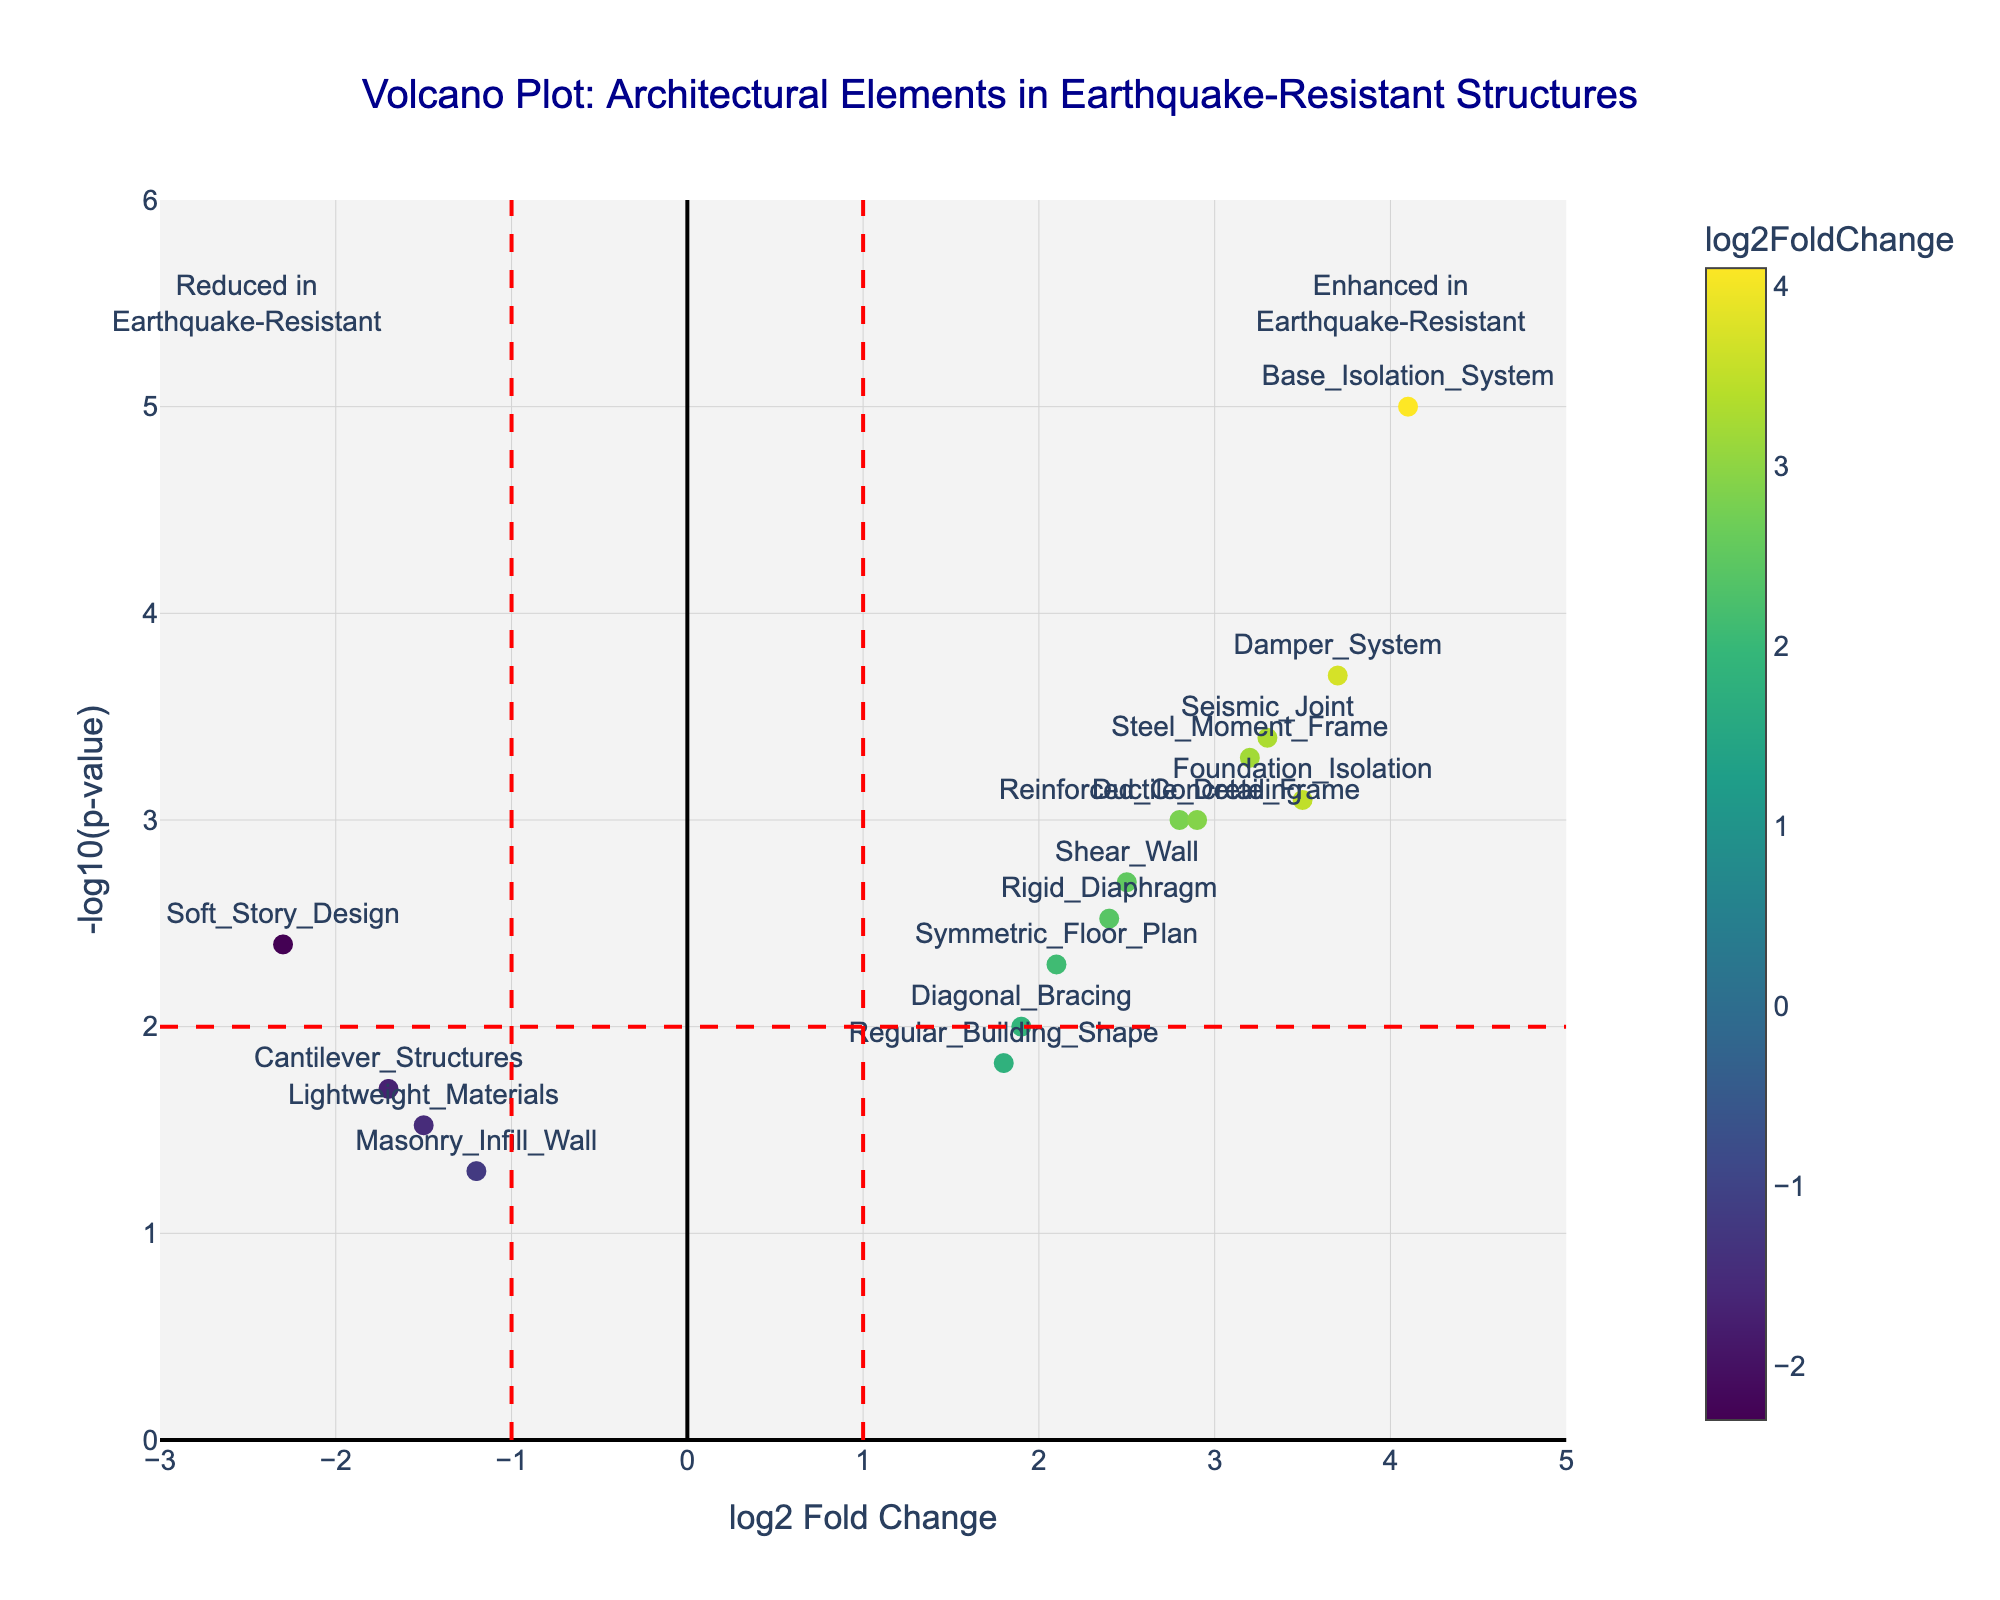What is the title of the figure? The title is usually located at the top of the figure, and it states what the plot represents.
Answer: Volcano Plot: Architectural Elements in Earthquake-Resistant Structures What are the axes labels in the plot? The x-axis label is "log2 Fold Change" and the y-axis label is "-log10(p-value)". These labels provide information on what each axis represents.
Answer: log2 Fold Change, -log10(p-value) How many architectural elements show a positive log2 fold change greater than 1? Elements with a positive log2 fold change greater than 1 are those that fall to the right of the vertical line at x=1, which is drawn in red. Count the number of points that meet this criterion.
Answer: 10 Which architectural element has the highest -log10(p-value)? The highest -log10(p-value) corresponds to the point located furthest up on the y-axis, representing the element with the strongest statistical significance.
Answer: Base_Isolation_System What is the log2 Fold Change and -log10(p-value) for the element "Soft_Story_Design"? Locate the point labeled "Soft_Story_Design" and read the corresponding x (log2 Fold Change) and y (-log10(p-value)) values from the plot.
Answer: -2.3, 2.40 How does the log2 Fold Change of "Reinforced_Concrete_Frame" compare to "Steel_Moment_Frame"? Find the points labeled with these elements and compare their positions on the x-axis.
Answer: Reinforced_Concrete_Frame has a lower log2 Fold Change compared to Steel_Moment_Frame What inference can be made about elements with negative log2 Fold Change? Elements with negative log2 Fold Change are towards the left of the vertical line at x=-1, meaning they are reduced in earthquake-resistant structures.
Answer: Reduced in earthquake-resistant structures Identify an architectural element that is significantly reduced in earthquake-resistant structures. Elements with negative log2 Fold Change less than -1 and -log10(p-value) greater than 2 are significantly reduced. Specifically, look for points in this region.
Answer: Soft_Story_Design How many elements show a statistically significant change with -log10(p-value) greater than 2? Points with -log10(p-value) greater than 2 rise above the horizontal red line marked at y=2. Count these points.
Answer: 11 What is the significance of the red dashed lines in the plot? The vertical dashed lines denote log2 Fold Change thresholds (x=-1 and x=1), and the horizontal dashed line denotes the p-value threshold (-log10(p-value)=2), highlighting significant changes.
Answer: Thresholds for significant change 